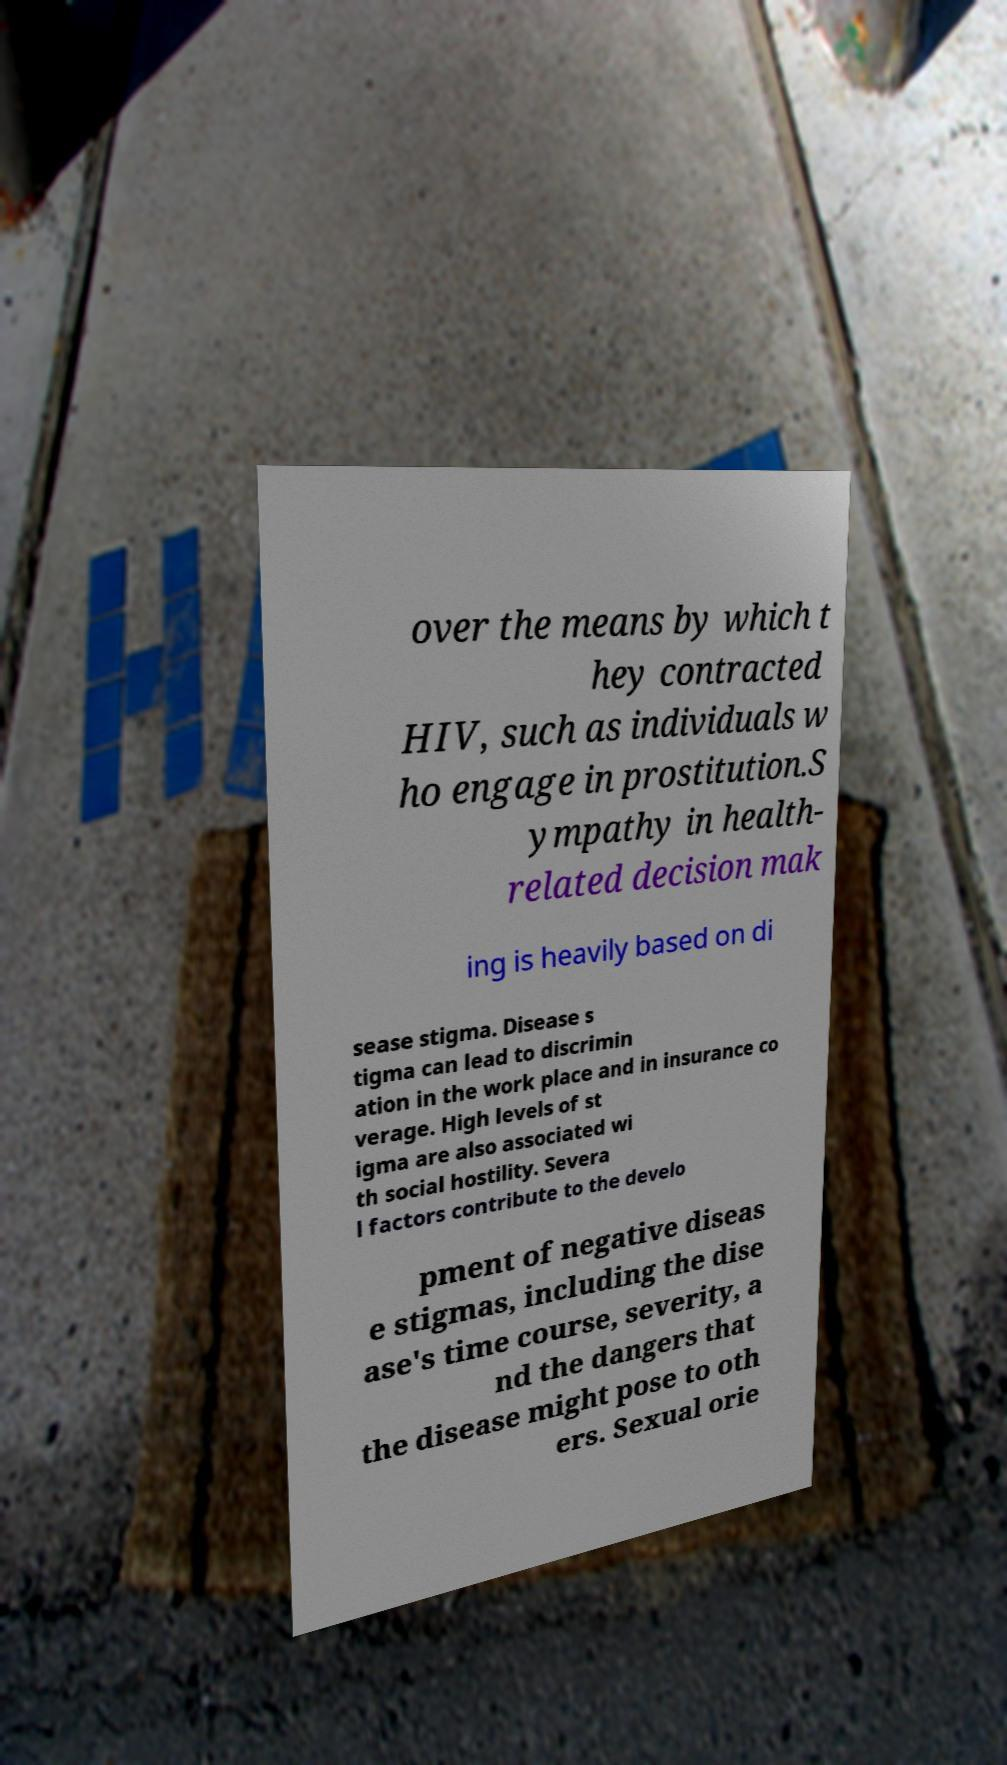For documentation purposes, I need the text within this image transcribed. Could you provide that? over the means by which t hey contracted HIV, such as individuals w ho engage in prostitution.S ympathy in health- related decision mak ing is heavily based on di sease stigma. Disease s tigma can lead to discrimin ation in the work place and in insurance co verage. High levels of st igma are also associated wi th social hostility. Severa l factors contribute to the develo pment of negative diseas e stigmas, including the dise ase's time course, severity, a nd the dangers that the disease might pose to oth ers. Sexual orie 